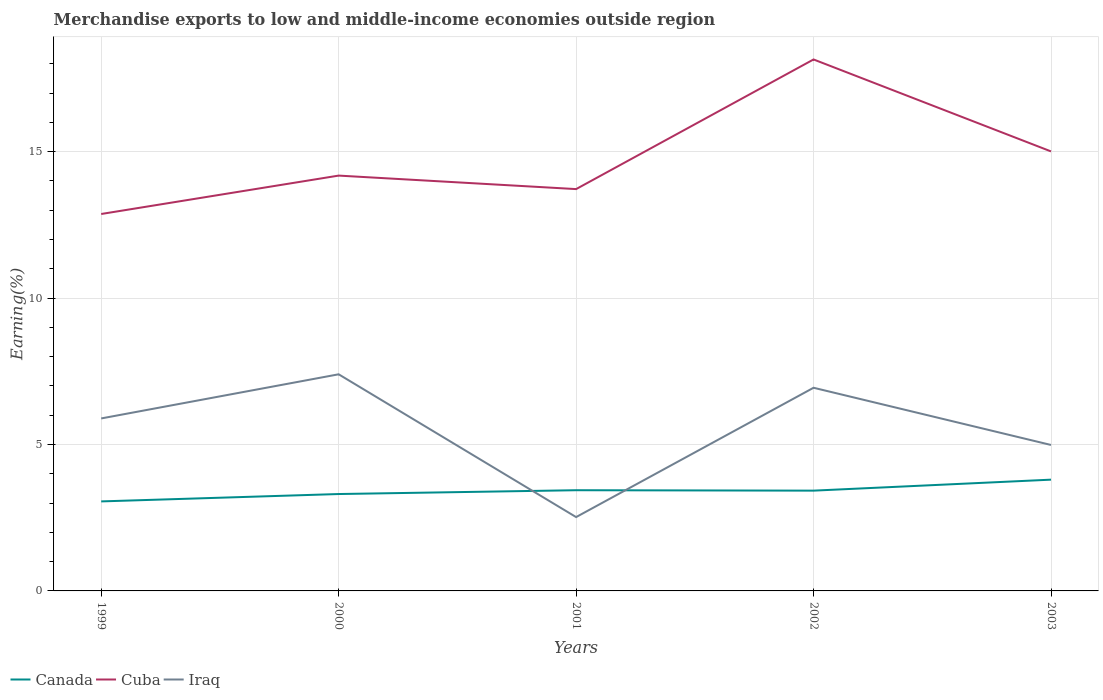How many different coloured lines are there?
Offer a terse response. 3. Across all years, what is the maximum percentage of amount earned from merchandise exports in Cuba?
Ensure brevity in your answer.  12.87. What is the total percentage of amount earned from merchandise exports in Cuba in the graph?
Your answer should be compact. 0.46. What is the difference between the highest and the second highest percentage of amount earned from merchandise exports in Canada?
Provide a succinct answer. 0.74. What is the difference between the highest and the lowest percentage of amount earned from merchandise exports in Iraq?
Your answer should be compact. 3. Is the percentage of amount earned from merchandise exports in Cuba strictly greater than the percentage of amount earned from merchandise exports in Iraq over the years?
Make the answer very short. No. How many years are there in the graph?
Provide a short and direct response. 5. What is the difference between two consecutive major ticks on the Y-axis?
Make the answer very short. 5. How are the legend labels stacked?
Provide a succinct answer. Horizontal. What is the title of the graph?
Make the answer very short. Merchandise exports to low and middle-income economies outside region. Does "Argentina" appear as one of the legend labels in the graph?
Your answer should be compact. No. What is the label or title of the X-axis?
Your answer should be compact. Years. What is the label or title of the Y-axis?
Make the answer very short. Earning(%). What is the Earning(%) of Canada in 1999?
Your response must be concise. 3.06. What is the Earning(%) in Cuba in 1999?
Provide a short and direct response. 12.87. What is the Earning(%) of Iraq in 1999?
Offer a very short reply. 5.89. What is the Earning(%) of Canada in 2000?
Offer a terse response. 3.31. What is the Earning(%) in Cuba in 2000?
Give a very brief answer. 14.18. What is the Earning(%) of Iraq in 2000?
Make the answer very short. 7.4. What is the Earning(%) in Canada in 2001?
Your answer should be very brief. 3.44. What is the Earning(%) of Cuba in 2001?
Provide a succinct answer. 13.72. What is the Earning(%) in Iraq in 2001?
Provide a succinct answer. 2.52. What is the Earning(%) of Canada in 2002?
Offer a very short reply. 3.42. What is the Earning(%) in Cuba in 2002?
Provide a succinct answer. 18.15. What is the Earning(%) in Iraq in 2002?
Give a very brief answer. 6.94. What is the Earning(%) of Canada in 2003?
Offer a very short reply. 3.8. What is the Earning(%) of Cuba in 2003?
Provide a succinct answer. 15.01. What is the Earning(%) in Iraq in 2003?
Make the answer very short. 4.98. Across all years, what is the maximum Earning(%) in Canada?
Keep it short and to the point. 3.8. Across all years, what is the maximum Earning(%) of Cuba?
Ensure brevity in your answer.  18.15. Across all years, what is the maximum Earning(%) in Iraq?
Keep it short and to the point. 7.4. Across all years, what is the minimum Earning(%) of Canada?
Offer a terse response. 3.06. Across all years, what is the minimum Earning(%) in Cuba?
Your answer should be very brief. 12.87. Across all years, what is the minimum Earning(%) in Iraq?
Give a very brief answer. 2.52. What is the total Earning(%) of Canada in the graph?
Your response must be concise. 17.03. What is the total Earning(%) of Cuba in the graph?
Provide a short and direct response. 73.92. What is the total Earning(%) of Iraq in the graph?
Provide a succinct answer. 27.73. What is the difference between the Earning(%) in Canada in 1999 and that in 2000?
Your answer should be very brief. -0.25. What is the difference between the Earning(%) in Cuba in 1999 and that in 2000?
Ensure brevity in your answer.  -1.31. What is the difference between the Earning(%) of Iraq in 1999 and that in 2000?
Keep it short and to the point. -1.51. What is the difference between the Earning(%) of Canada in 1999 and that in 2001?
Offer a terse response. -0.38. What is the difference between the Earning(%) in Cuba in 1999 and that in 2001?
Make the answer very short. -0.85. What is the difference between the Earning(%) in Iraq in 1999 and that in 2001?
Provide a succinct answer. 3.37. What is the difference between the Earning(%) of Canada in 1999 and that in 2002?
Your answer should be very brief. -0.37. What is the difference between the Earning(%) in Cuba in 1999 and that in 2002?
Keep it short and to the point. -5.28. What is the difference between the Earning(%) of Iraq in 1999 and that in 2002?
Ensure brevity in your answer.  -1.05. What is the difference between the Earning(%) of Canada in 1999 and that in 2003?
Ensure brevity in your answer.  -0.74. What is the difference between the Earning(%) in Cuba in 1999 and that in 2003?
Provide a succinct answer. -2.14. What is the difference between the Earning(%) in Iraq in 1999 and that in 2003?
Offer a very short reply. 0.91. What is the difference between the Earning(%) of Canada in 2000 and that in 2001?
Your answer should be very brief. -0.13. What is the difference between the Earning(%) of Cuba in 2000 and that in 2001?
Give a very brief answer. 0.46. What is the difference between the Earning(%) in Iraq in 2000 and that in 2001?
Ensure brevity in your answer.  4.88. What is the difference between the Earning(%) of Canada in 2000 and that in 2002?
Make the answer very short. -0.12. What is the difference between the Earning(%) of Cuba in 2000 and that in 2002?
Offer a very short reply. -3.97. What is the difference between the Earning(%) in Iraq in 2000 and that in 2002?
Provide a succinct answer. 0.46. What is the difference between the Earning(%) of Canada in 2000 and that in 2003?
Ensure brevity in your answer.  -0.49. What is the difference between the Earning(%) in Cuba in 2000 and that in 2003?
Give a very brief answer. -0.83. What is the difference between the Earning(%) of Iraq in 2000 and that in 2003?
Provide a succinct answer. 2.41. What is the difference between the Earning(%) of Canada in 2001 and that in 2002?
Ensure brevity in your answer.  0.01. What is the difference between the Earning(%) of Cuba in 2001 and that in 2002?
Make the answer very short. -4.43. What is the difference between the Earning(%) of Iraq in 2001 and that in 2002?
Your answer should be very brief. -4.42. What is the difference between the Earning(%) of Canada in 2001 and that in 2003?
Your answer should be very brief. -0.36. What is the difference between the Earning(%) in Cuba in 2001 and that in 2003?
Your response must be concise. -1.29. What is the difference between the Earning(%) in Iraq in 2001 and that in 2003?
Provide a succinct answer. -2.46. What is the difference between the Earning(%) of Canada in 2002 and that in 2003?
Offer a terse response. -0.37. What is the difference between the Earning(%) of Cuba in 2002 and that in 2003?
Provide a short and direct response. 3.14. What is the difference between the Earning(%) in Iraq in 2002 and that in 2003?
Give a very brief answer. 1.95. What is the difference between the Earning(%) in Canada in 1999 and the Earning(%) in Cuba in 2000?
Make the answer very short. -11.12. What is the difference between the Earning(%) of Canada in 1999 and the Earning(%) of Iraq in 2000?
Your answer should be compact. -4.34. What is the difference between the Earning(%) of Cuba in 1999 and the Earning(%) of Iraq in 2000?
Make the answer very short. 5.47. What is the difference between the Earning(%) of Canada in 1999 and the Earning(%) of Cuba in 2001?
Provide a short and direct response. -10.66. What is the difference between the Earning(%) in Canada in 1999 and the Earning(%) in Iraq in 2001?
Give a very brief answer. 0.54. What is the difference between the Earning(%) of Cuba in 1999 and the Earning(%) of Iraq in 2001?
Keep it short and to the point. 10.35. What is the difference between the Earning(%) in Canada in 1999 and the Earning(%) in Cuba in 2002?
Provide a short and direct response. -15.09. What is the difference between the Earning(%) in Canada in 1999 and the Earning(%) in Iraq in 2002?
Your response must be concise. -3.88. What is the difference between the Earning(%) in Cuba in 1999 and the Earning(%) in Iraq in 2002?
Your response must be concise. 5.93. What is the difference between the Earning(%) in Canada in 1999 and the Earning(%) in Cuba in 2003?
Keep it short and to the point. -11.95. What is the difference between the Earning(%) of Canada in 1999 and the Earning(%) of Iraq in 2003?
Offer a very short reply. -1.93. What is the difference between the Earning(%) in Cuba in 1999 and the Earning(%) in Iraq in 2003?
Ensure brevity in your answer.  7.89. What is the difference between the Earning(%) in Canada in 2000 and the Earning(%) in Cuba in 2001?
Provide a short and direct response. -10.41. What is the difference between the Earning(%) of Canada in 2000 and the Earning(%) of Iraq in 2001?
Offer a very short reply. 0.79. What is the difference between the Earning(%) in Cuba in 2000 and the Earning(%) in Iraq in 2001?
Ensure brevity in your answer.  11.66. What is the difference between the Earning(%) of Canada in 2000 and the Earning(%) of Cuba in 2002?
Give a very brief answer. -14.84. What is the difference between the Earning(%) in Canada in 2000 and the Earning(%) in Iraq in 2002?
Your answer should be compact. -3.63. What is the difference between the Earning(%) in Cuba in 2000 and the Earning(%) in Iraq in 2002?
Your answer should be compact. 7.24. What is the difference between the Earning(%) in Canada in 2000 and the Earning(%) in Cuba in 2003?
Your response must be concise. -11.7. What is the difference between the Earning(%) of Canada in 2000 and the Earning(%) of Iraq in 2003?
Your response must be concise. -1.68. What is the difference between the Earning(%) of Cuba in 2000 and the Earning(%) of Iraq in 2003?
Ensure brevity in your answer.  9.2. What is the difference between the Earning(%) of Canada in 2001 and the Earning(%) of Cuba in 2002?
Your response must be concise. -14.71. What is the difference between the Earning(%) of Canada in 2001 and the Earning(%) of Iraq in 2002?
Provide a succinct answer. -3.5. What is the difference between the Earning(%) in Cuba in 2001 and the Earning(%) in Iraq in 2002?
Provide a succinct answer. 6.78. What is the difference between the Earning(%) of Canada in 2001 and the Earning(%) of Cuba in 2003?
Keep it short and to the point. -11.57. What is the difference between the Earning(%) in Canada in 2001 and the Earning(%) in Iraq in 2003?
Ensure brevity in your answer.  -1.54. What is the difference between the Earning(%) in Cuba in 2001 and the Earning(%) in Iraq in 2003?
Offer a terse response. 8.74. What is the difference between the Earning(%) in Canada in 2002 and the Earning(%) in Cuba in 2003?
Offer a terse response. -11.58. What is the difference between the Earning(%) in Canada in 2002 and the Earning(%) in Iraq in 2003?
Your answer should be compact. -1.56. What is the difference between the Earning(%) in Cuba in 2002 and the Earning(%) in Iraq in 2003?
Your answer should be compact. 13.16. What is the average Earning(%) of Canada per year?
Make the answer very short. 3.41. What is the average Earning(%) in Cuba per year?
Offer a terse response. 14.78. What is the average Earning(%) of Iraq per year?
Your response must be concise. 5.55. In the year 1999, what is the difference between the Earning(%) in Canada and Earning(%) in Cuba?
Provide a short and direct response. -9.81. In the year 1999, what is the difference between the Earning(%) in Canada and Earning(%) in Iraq?
Your answer should be compact. -2.83. In the year 1999, what is the difference between the Earning(%) in Cuba and Earning(%) in Iraq?
Your response must be concise. 6.98. In the year 2000, what is the difference between the Earning(%) of Canada and Earning(%) of Cuba?
Offer a very short reply. -10.87. In the year 2000, what is the difference between the Earning(%) in Canada and Earning(%) in Iraq?
Make the answer very short. -4.09. In the year 2000, what is the difference between the Earning(%) in Cuba and Earning(%) in Iraq?
Make the answer very short. 6.78. In the year 2001, what is the difference between the Earning(%) in Canada and Earning(%) in Cuba?
Your answer should be very brief. -10.28. In the year 2001, what is the difference between the Earning(%) in Canada and Earning(%) in Iraq?
Provide a short and direct response. 0.92. In the year 2001, what is the difference between the Earning(%) in Cuba and Earning(%) in Iraq?
Keep it short and to the point. 11.2. In the year 2002, what is the difference between the Earning(%) in Canada and Earning(%) in Cuba?
Your response must be concise. -14.72. In the year 2002, what is the difference between the Earning(%) of Canada and Earning(%) of Iraq?
Offer a terse response. -3.51. In the year 2002, what is the difference between the Earning(%) in Cuba and Earning(%) in Iraq?
Offer a terse response. 11.21. In the year 2003, what is the difference between the Earning(%) in Canada and Earning(%) in Cuba?
Provide a succinct answer. -11.21. In the year 2003, what is the difference between the Earning(%) of Canada and Earning(%) of Iraq?
Your answer should be very brief. -1.18. In the year 2003, what is the difference between the Earning(%) in Cuba and Earning(%) in Iraq?
Give a very brief answer. 10.02. What is the ratio of the Earning(%) in Canada in 1999 to that in 2000?
Offer a terse response. 0.92. What is the ratio of the Earning(%) of Cuba in 1999 to that in 2000?
Provide a succinct answer. 0.91. What is the ratio of the Earning(%) in Iraq in 1999 to that in 2000?
Provide a short and direct response. 0.8. What is the ratio of the Earning(%) of Canada in 1999 to that in 2001?
Provide a succinct answer. 0.89. What is the ratio of the Earning(%) of Cuba in 1999 to that in 2001?
Provide a succinct answer. 0.94. What is the ratio of the Earning(%) of Iraq in 1999 to that in 2001?
Give a very brief answer. 2.34. What is the ratio of the Earning(%) in Canada in 1999 to that in 2002?
Provide a succinct answer. 0.89. What is the ratio of the Earning(%) of Cuba in 1999 to that in 2002?
Offer a terse response. 0.71. What is the ratio of the Earning(%) in Iraq in 1999 to that in 2002?
Offer a terse response. 0.85. What is the ratio of the Earning(%) of Canada in 1999 to that in 2003?
Your answer should be compact. 0.8. What is the ratio of the Earning(%) in Cuba in 1999 to that in 2003?
Offer a very short reply. 0.86. What is the ratio of the Earning(%) of Iraq in 1999 to that in 2003?
Offer a terse response. 1.18. What is the ratio of the Earning(%) in Canada in 2000 to that in 2001?
Ensure brevity in your answer.  0.96. What is the ratio of the Earning(%) of Cuba in 2000 to that in 2001?
Provide a succinct answer. 1.03. What is the ratio of the Earning(%) in Iraq in 2000 to that in 2001?
Offer a terse response. 2.93. What is the ratio of the Earning(%) of Canada in 2000 to that in 2002?
Offer a very short reply. 0.97. What is the ratio of the Earning(%) of Cuba in 2000 to that in 2002?
Keep it short and to the point. 0.78. What is the ratio of the Earning(%) of Iraq in 2000 to that in 2002?
Give a very brief answer. 1.07. What is the ratio of the Earning(%) of Canada in 2000 to that in 2003?
Your answer should be very brief. 0.87. What is the ratio of the Earning(%) in Cuba in 2000 to that in 2003?
Ensure brevity in your answer.  0.94. What is the ratio of the Earning(%) in Iraq in 2000 to that in 2003?
Your response must be concise. 1.48. What is the ratio of the Earning(%) of Cuba in 2001 to that in 2002?
Ensure brevity in your answer.  0.76. What is the ratio of the Earning(%) in Iraq in 2001 to that in 2002?
Make the answer very short. 0.36. What is the ratio of the Earning(%) in Canada in 2001 to that in 2003?
Ensure brevity in your answer.  0.91. What is the ratio of the Earning(%) of Cuba in 2001 to that in 2003?
Your answer should be compact. 0.91. What is the ratio of the Earning(%) in Iraq in 2001 to that in 2003?
Provide a short and direct response. 0.51. What is the ratio of the Earning(%) of Canada in 2002 to that in 2003?
Your answer should be compact. 0.9. What is the ratio of the Earning(%) in Cuba in 2002 to that in 2003?
Offer a very short reply. 1.21. What is the ratio of the Earning(%) in Iraq in 2002 to that in 2003?
Give a very brief answer. 1.39. What is the difference between the highest and the second highest Earning(%) in Canada?
Your response must be concise. 0.36. What is the difference between the highest and the second highest Earning(%) of Cuba?
Ensure brevity in your answer.  3.14. What is the difference between the highest and the second highest Earning(%) in Iraq?
Your answer should be compact. 0.46. What is the difference between the highest and the lowest Earning(%) of Canada?
Offer a terse response. 0.74. What is the difference between the highest and the lowest Earning(%) in Cuba?
Offer a very short reply. 5.28. What is the difference between the highest and the lowest Earning(%) in Iraq?
Ensure brevity in your answer.  4.88. 